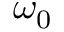<formula> <loc_0><loc_0><loc_500><loc_500>\omega _ { 0 }</formula> 